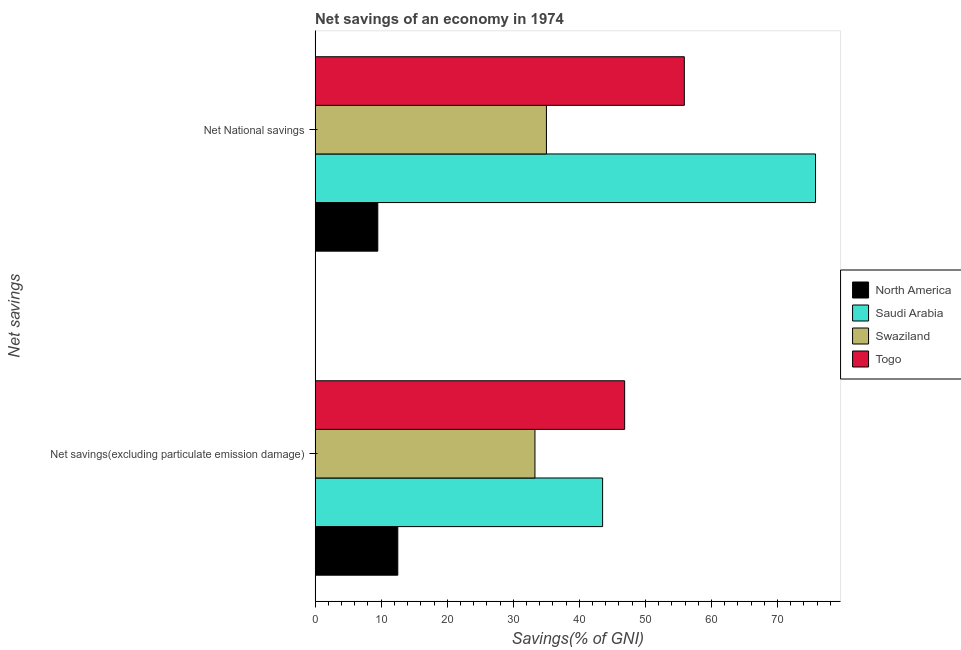How many different coloured bars are there?
Offer a terse response. 4. Are the number of bars per tick equal to the number of legend labels?
Provide a succinct answer. Yes. Are the number of bars on each tick of the Y-axis equal?
Your answer should be very brief. Yes. How many bars are there on the 1st tick from the top?
Your response must be concise. 4. How many bars are there on the 1st tick from the bottom?
Your answer should be compact. 4. What is the label of the 2nd group of bars from the top?
Offer a very short reply. Net savings(excluding particulate emission damage). What is the net savings(excluding particulate emission damage) in North America?
Your response must be concise. 12.52. Across all countries, what is the maximum net national savings?
Provide a short and direct response. 75.76. Across all countries, what is the minimum net national savings?
Your answer should be compact. 9.49. In which country was the net national savings maximum?
Your response must be concise. Saudi Arabia. What is the total net national savings in the graph?
Give a very brief answer. 176.16. What is the difference between the net national savings in Togo and that in Swaziland?
Your answer should be compact. 20.87. What is the difference between the net savings(excluding particulate emission damage) in North America and the net national savings in Saudi Arabia?
Ensure brevity in your answer.  -63.24. What is the average net national savings per country?
Make the answer very short. 44.04. What is the difference between the net savings(excluding particulate emission damage) and net national savings in Saudi Arabia?
Offer a very short reply. -32.23. What is the ratio of the net savings(excluding particulate emission damage) in North America to that in Swaziland?
Keep it short and to the point. 0.38. Is the net national savings in Togo less than that in Saudi Arabia?
Provide a short and direct response. Yes. In how many countries, is the net national savings greater than the average net national savings taken over all countries?
Provide a short and direct response. 2. What does the 4th bar from the top in Net National savings represents?
Make the answer very short. North America. What does the 4th bar from the bottom in Net National savings represents?
Ensure brevity in your answer.  Togo. Are all the bars in the graph horizontal?
Offer a terse response. Yes. How many countries are there in the graph?
Keep it short and to the point. 4. Does the graph contain any zero values?
Ensure brevity in your answer.  No. Does the graph contain grids?
Your answer should be compact. No. How many legend labels are there?
Provide a short and direct response. 4. What is the title of the graph?
Your response must be concise. Net savings of an economy in 1974. What is the label or title of the X-axis?
Your answer should be very brief. Savings(% of GNI). What is the label or title of the Y-axis?
Make the answer very short. Net savings. What is the Savings(% of GNI) in North America in Net savings(excluding particulate emission damage)?
Keep it short and to the point. 12.52. What is the Savings(% of GNI) of Saudi Arabia in Net savings(excluding particulate emission damage)?
Offer a very short reply. 43.52. What is the Savings(% of GNI) of Swaziland in Net savings(excluding particulate emission damage)?
Ensure brevity in your answer.  33.28. What is the Savings(% of GNI) in Togo in Net savings(excluding particulate emission damage)?
Keep it short and to the point. 46.86. What is the Savings(% of GNI) in North America in Net National savings?
Keep it short and to the point. 9.49. What is the Savings(% of GNI) of Saudi Arabia in Net National savings?
Your answer should be very brief. 75.76. What is the Savings(% of GNI) in Swaziland in Net National savings?
Offer a very short reply. 35.02. What is the Savings(% of GNI) in Togo in Net National savings?
Offer a very short reply. 55.89. Across all Net savings, what is the maximum Savings(% of GNI) of North America?
Offer a terse response. 12.52. Across all Net savings, what is the maximum Savings(% of GNI) in Saudi Arabia?
Ensure brevity in your answer.  75.76. Across all Net savings, what is the maximum Savings(% of GNI) of Swaziland?
Your response must be concise. 35.02. Across all Net savings, what is the maximum Savings(% of GNI) of Togo?
Your answer should be very brief. 55.89. Across all Net savings, what is the minimum Savings(% of GNI) of North America?
Your response must be concise. 9.49. Across all Net savings, what is the minimum Savings(% of GNI) in Saudi Arabia?
Make the answer very short. 43.52. Across all Net savings, what is the minimum Savings(% of GNI) of Swaziland?
Keep it short and to the point. 33.28. Across all Net savings, what is the minimum Savings(% of GNI) in Togo?
Offer a terse response. 46.86. What is the total Savings(% of GNI) of North America in the graph?
Give a very brief answer. 22.01. What is the total Savings(% of GNI) of Saudi Arabia in the graph?
Keep it short and to the point. 119.28. What is the total Savings(% of GNI) of Swaziland in the graph?
Provide a short and direct response. 68.3. What is the total Savings(% of GNI) of Togo in the graph?
Provide a succinct answer. 102.75. What is the difference between the Savings(% of GNI) in North America in Net savings(excluding particulate emission damage) and that in Net National savings?
Your response must be concise. 3.03. What is the difference between the Savings(% of GNI) in Saudi Arabia in Net savings(excluding particulate emission damage) and that in Net National savings?
Give a very brief answer. -32.23. What is the difference between the Savings(% of GNI) of Swaziland in Net savings(excluding particulate emission damage) and that in Net National savings?
Your answer should be compact. -1.74. What is the difference between the Savings(% of GNI) of Togo in Net savings(excluding particulate emission damage) and that in Net National savings?
Offer a very short reply. -9.03. What is the difference between the Savings(% of GNI) in North America in Net savings(excluding particulate emission damage) and the Savings(% of GNI) in Saudi Arabia in Net National savings?
Make the answer very short. -63.24. What is the difference between the Savings(% of GNI) in North America in Net savings(excluding particulate emission damage) and the Savings(% of GNI) in Swaziland in Net National savings?
Provide a succinct answer. -22.5. What is the difference between the Savings(% of GNI) in North America in Net savings(excluding particulate emission damage) and the Savings(% of GNI) in Togo in Net National savings?
Your answer should be compact. -43.37. What is the difference between the Savings(% of GNI) in Saudi Arabia in Net savings(excluding particulate emission damage) and the Savings(% of GNI) in Swaziland in Net National savings?
Ensure brevity in your answer.  8.5. What is the difference between the Savings(% of GNI) in Saudi Arabia in Net savings(excluding particulate emission damage) and the Savings(% of GNI) in Togo in Net National savings?
Your answer should be compact. -12.37. What is the difference between the Savings(% of GNI) in Swaziland in Net savings(excluding particulate emission damage) and the Savings(% of GNI) in Togo in Net National savings?
Give a very brief answer. -22.61. What is the average Savings(% of GNI) of North America per Net savings?
Give a very brief answer. 11.01. What is the average Savings(% of GNI) in Saudi Arabia per Net savings?
Offer a very short reply. 59.64. What is the average Savings(% of GNI) in Swaziland per Net savings?
Provide a short and direct response. 34.15. What is the average Savings(% of GNI) of Togo per Net savings?
Provide a short and direct response. 51.38. What is the difference between the Savings(% of GNI) in North America and Savings(% of GNI) in Saudi Arabia in Net savings(excluding particulate emission damage)?
Provide a short and direct response. -31. What is the difference between the Savings(% of GNI) in North America and Savings(% of GNI) in Swaziland in Net savings(excluding particulate emission damage)?
Provide a succinct answer. -20.76. What is the difference between the Savings(% of GNI) of North America and Savings(% of GNI) of Togo in Net savings(excluding particulate emission damage)?
Your answer should be very brief. -34.34. What is the difference between the Savings(% of GNI) in Saudi Arabia and Savings(% of GNI) in Swaziland in Net savings(excluding particulate emission damage)?
Keep it short and to the point. 10.24. What is the difference between the Savings(% of GNI) in Saudi Arabia and Savings(% of GNI) in Togo in Net savings(excluding particulate emission damage)?
Offer a terse response. -3.34. What is the difference between the Savings(% of GNI) in Swaziland and Savings(% of GNI) in Togo in Net savings(excluding particulate emission damage)?
Your answer should be very brief. -13.58. What is the difference between the Savings(% of GNI) of North America and Savings(% of GNI) of Saudi Arabia in Net National savings?
Your response must be concise. -66.27. What is the difference between the Savings(% of GNI) in North America and Savings(% of GNI) in Swaziland in Net National savings?
Ensure brevity in your answer.  -25.53. What is the difference between the Savings(% of GNI) in North America and Savings(% of GNI) in Togo in Net National savings?
Make the answer very short. -46.4. What is the difference between the Savings(% of GNI) in Saudi Arabia and Savings(% of GNI) in Swaziland in Net National savings?
Provide a short and direct response. 40.74. What is the difference between the Savings(% of GNI) of Saudi Arabia and Savings(% of GNI) of Togo in Net National savings?
Offer a terse response. 19.86. What is the difference between the Savings(% of GNI) in Swaziland and Savings(% of GNI) in Togo in Net National savings?
Keep it short and to the point. -20.87. What is the ratio of the Savings(% of GNI) of North America in Net savings(excluding particulate emission damage) to that in Net National savings?
Give a very brief answer. 1.32. What is the ratio of the Savings(% of GNI) of Saudi Arabia in Net savings(excluding particulate emission damage) to that in Net National savings?
Your answer should be compact. 0.57. What is the ratio of the Savings(% of GNI) in Swaziland in Net savings(excluding particulate emission damage) to that in Net National savings?
Give a very brief answer. 0.95. What is the ratio of the Savings(% of GNI) of Togo in Net savings(excluding particulate emission damage) to that in Net National savings?
Make the answer very short. 0.84. What is the difference between the highest and the second highest Savings(% of GNI) of North America?
Your answer should be compact. 3.03. What is the difference between the highest and the second highest Savings(% of GNI) of Saudi Arabia?
Your response must be concise. 32.23. What is the difference between the highest and the second highest Savings(% of GNI) of Swaziland?
Give a very brief answer. 1.74. What is the difference between the highest and the second highest Savings(% of GNI) in Togo?
Your answer should be very brief. 9.03. What is the difference between the highest and the lowest Savings(% of GNI) in North America?
Provide a succinct answer. 3.03. What is the difference between the highest and the lowest Savings(% of GNI) of Saudi Arabia?
Provide a short and direct response. 32.23. What is the difference between the highest and the lowest Savings(% of GNI) of Swaziland?
Give a very brief answer. 1.74. What is the difference between the highest and the lowest Savings(% of GNI) of Togo?
Provide a short and direct response. 9.03. 